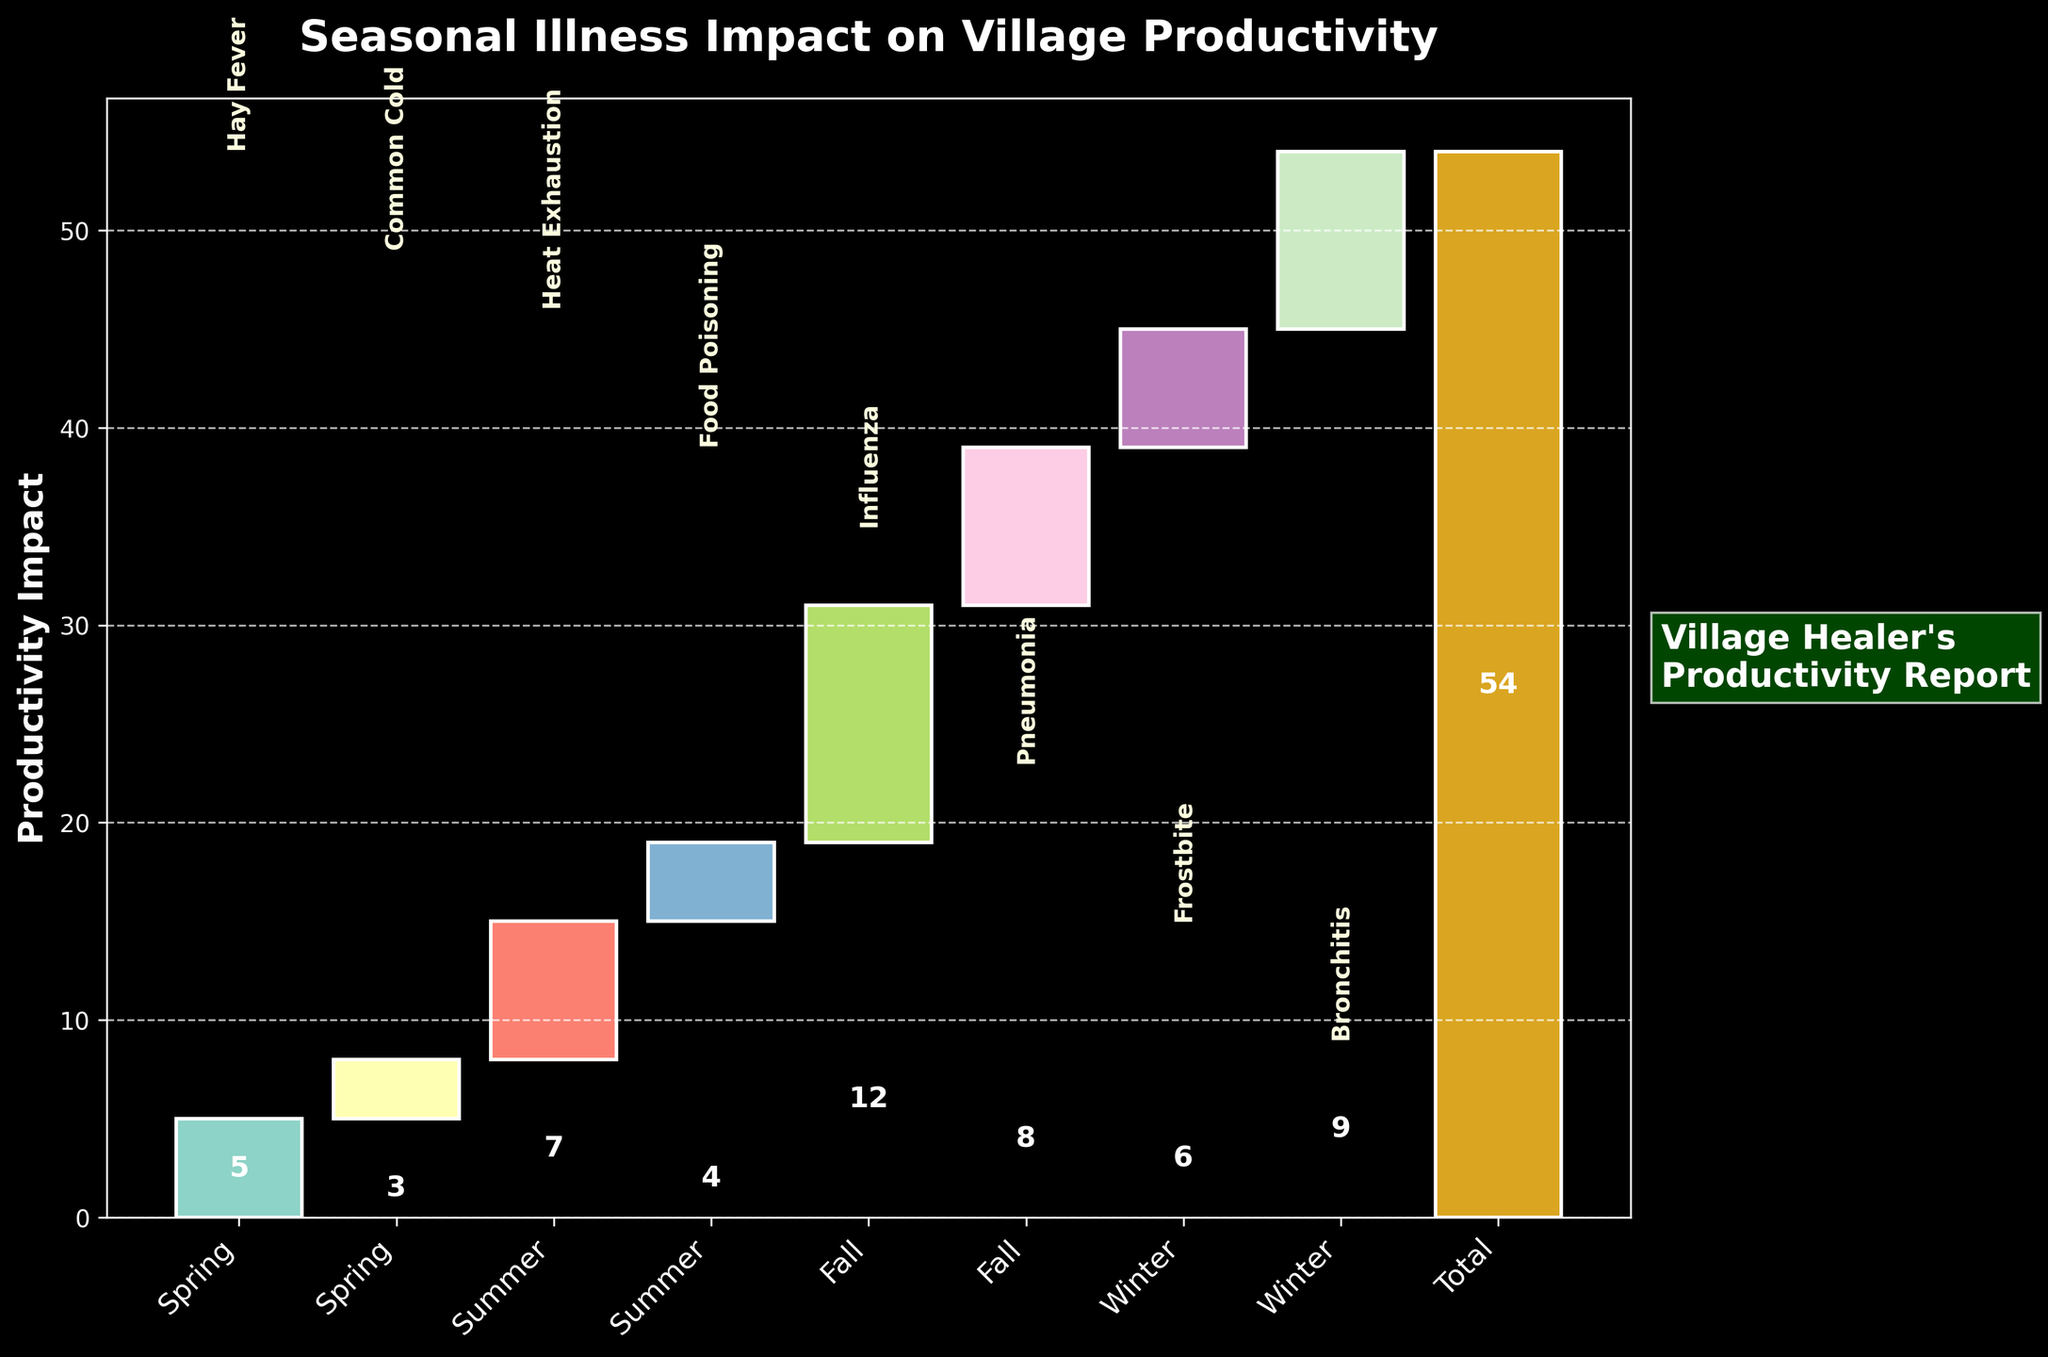What's the title of the chart? The title is written in bold text at the top of the chart. It provides a summary of what the chart represents.
Answer: Seasonal Illness Impact on Village Productivity Which illness in spring has the higher impact on productivity? Observing the spring season and comparing the impact values of the illnesses listed, the larger bar indicates a higher impact.
Answer: Hay Fever How much total productivity impact is attributed to illnesses in the summer season? Sum the productivity impacts of illnesses occurring in summer: Heat Exhaustion (7) + Food Poisoning (4).
Answer: 11 Which illness has the greatest individual impact on productivity? Compare the heights of all the bars representing each illness's impact; the tallest bar indicates the greatest impact.
Answer: Influenza How does the impact of Pneumonia compare to Bronchitis? Find the bars for Pneumonia and Bronchitis and compare their heights to see which is taller.
Answer: Pneumonia has a lower impact than Bronchitis What is the total productivity impact from winter illnesses? Sum the impacts of illnesses listed in winter: Frostbite (6) + Bronchitis (9).
Answer: 15 How many different illnesses are shown on the chart? Count the labels for distinct illnesses on the chart.
Answer: 8 Is the total productivity impact greater or less than the sum of all individual impacts? Add up all individual impacts and compare with the final bar labeled "Total Impact". Note that they should match since the total is the cumulative effect.
Answer: Equal Which season has the highest cumulative productivity impact from illnesses? Compare the combined heights of the bars for each season to determine the largest cumulative impact.
Answer: Fall What is the cumulative productivity impact after the first illness? Identify the height of the first bar representing the first illness (Hay Fever).
Answer: 5 